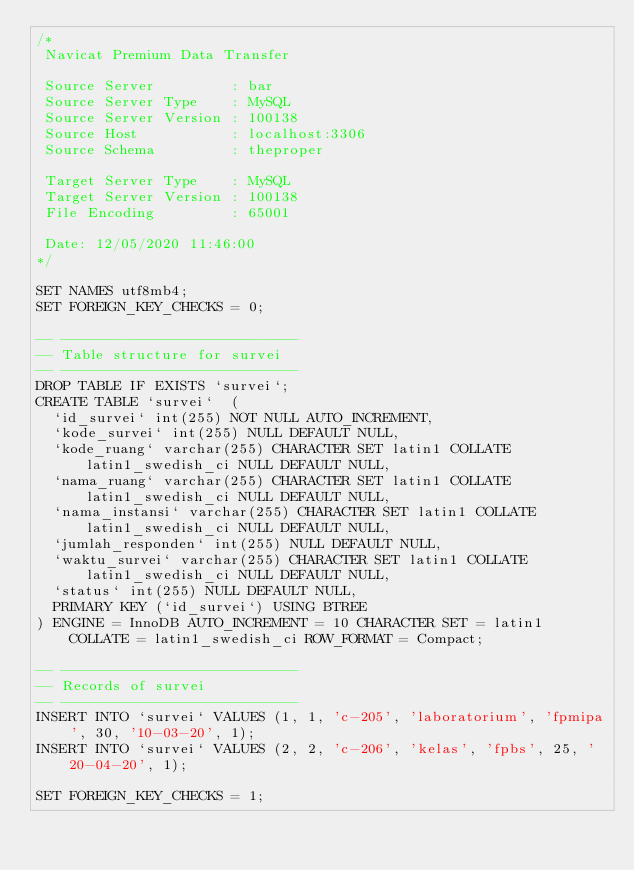<code> <loc_0><loc_0><loc_500><loc_500><_SQL_>/*
 Navicat Premium Data Transfer

 Source Server         : bar
 Source Server Type    : MySQL
 Source Server Version : 100138
 Source Host           : localhost:3306
 Source Schema         : theproper

 Target Server Type    : MySQL
 Target Server Version : 100138
 File Encoding         : 65001

 Date: 12/05/2020 11:46:00
*/

SET NAMES utf8mb4;
SET FOREIGN_KEY_CHECKS = 0;

-- ----------------------------
-- Table structure for survei
-- ----------------------------
DROP TABLE IF EXISTS `survei`;
CREATE TABLE `survei`  (
  `id_survei` int(255) NOT NULL AUTO_INCREMENT,
  `kode_survei` int(255) NULL DEFAULT NULL,
  `kode_ruang` varchar(255) CHARACTER SET latin1 COLLATE latin1_swedish_ci NULL DEFAULT NULL,
  `nama_ruang` varchar(255) CHARACTER SET latin1 COLLATE latin1_swedish_ci NULL DEFAULT NULL,
  `nama_instansi` varchar(255) CHARACTER SET latin1 COLLATE latin1_swedish_ci NULL DEFAULT NULL,
  `jumlah_responden` int(255) NULL DEFAULT NULL,
  `waktu_survei` varchar(255) CHARACTER SET latin1 COLLATE latin1_swedish_ci NULL DEFAULT NULL,
  `status` int(255) NULL DEFAULT NULL,
  PRIMARY KEY (`id_survei`) USING BTREE
) ENGINE = InnoDB AUTO_INCREMENT = 10 CHARACTER SET = latin1 COLLATE = latin1_swedish_ci ROW_FORMAT = Compact;

-- ----------------------------
-- Records of survei
-- ----------------------------
INSERT INTO `survei` VALUES (1, 1, 'c-205', 'laboratorium', 'fpmipa', 30, '10-03-20', 1);
INSERT INTO `survei` VALUES (2, 2, 'c-206', 'kelas', 'fpbs', 25, '20-04-20', 1);

SET FOREIGN_KEY_CHECKS = 1;
</code> 